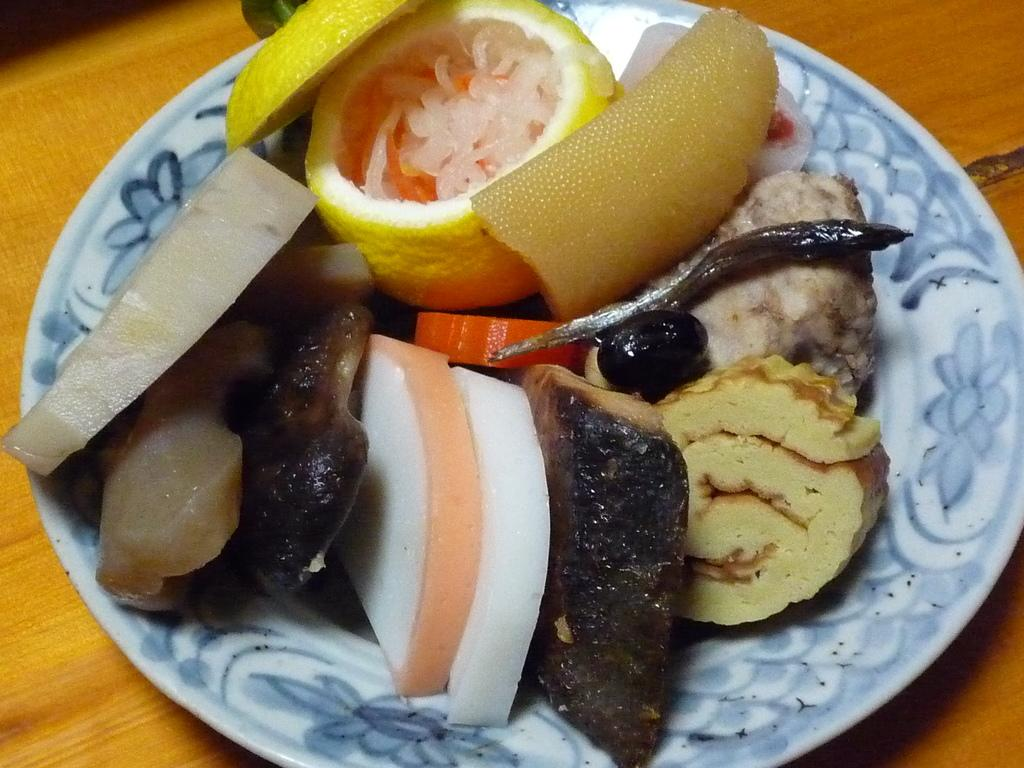What type of surface is visible in the image? There is a wooden surface in the image. What is located above the wooden surface? There is a plate above the wooden surface. What is on the plate? There is food on the plate. What is the wish of the person who placed the food on the plate? There is no information about a person's wish in the image, as it only shows a wooden surface, a plate, and food on the plate. 